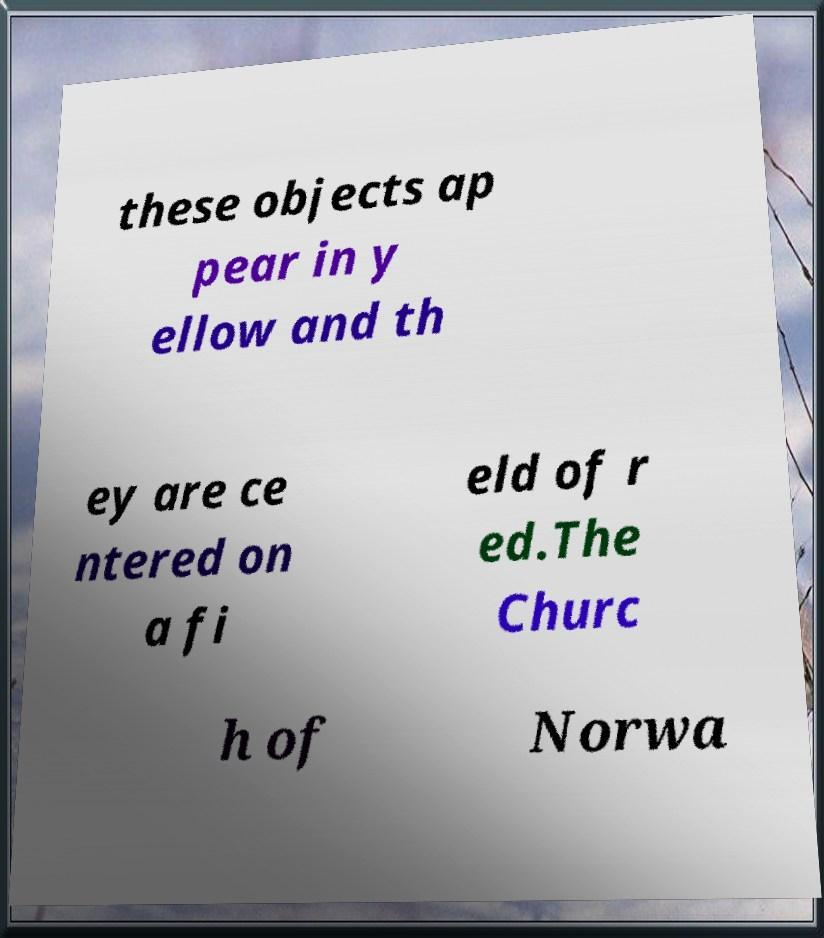Please read and relay the text visible in this image. What does it say? these objects ap pear in y ellow and th ey are ce ntered on a fi eld of r ed.The Churc h of Norwa 